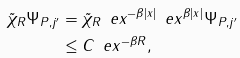Convert formula to latex. <formula><loc_0><loc_0><loc_500><loc_500>\| \tilde { \chi } _ { R } \Psi _ { P , j ^ { \prime } } \| & = \| \tilde { \chi } _ { R } \, \ e x ^ { - \beta | x | } \, \ e x ^ { \beta | x | } \Psi _ { P , j ^ { \prime } } \| \\ & \leq C \, \ e x ^ { - \beta R } ,</formula> 